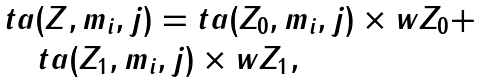<formula> <loc_0><loc_0><loc_500><loc_500>\begin{array} { l } { t a ( Z , m _ { i } , j ) = t a ( Z _ { 0 } , m _ { i } , j ) \times { w Z _ { 0 } } + } \\ { \quad t a ( Z _ { 1 } , m _ { i } , j ) \times { w Z _ { 1 } } } , \\ \end{array}</formula> 